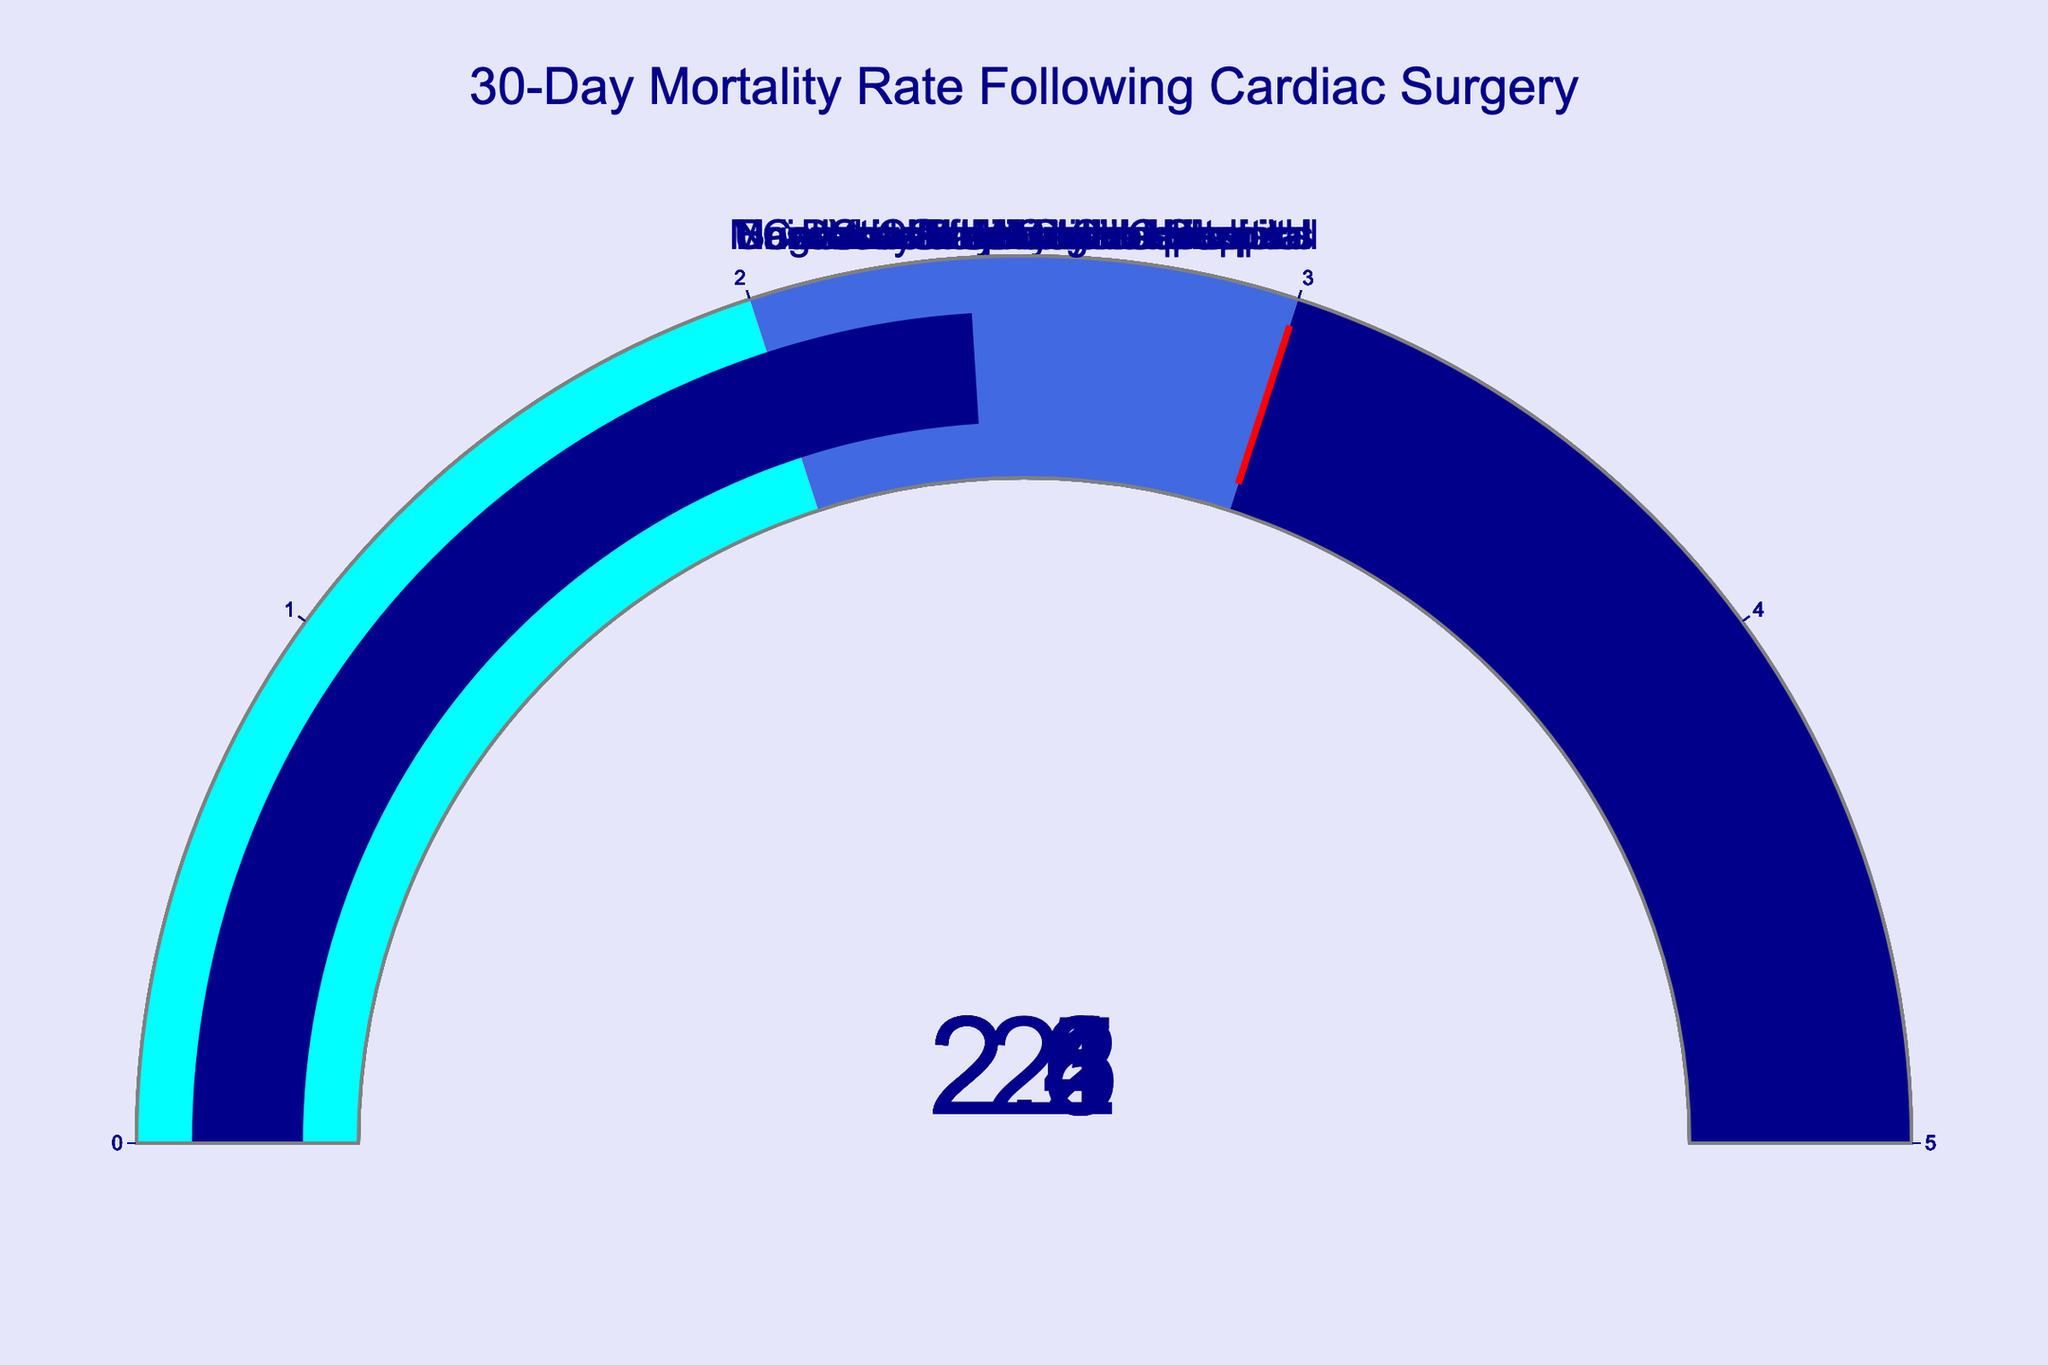What's the highest 30-day mortality rate displayed? The highest mortality rate is found by looking at each gauge and identifying the largest value shown among them. Cedars-Sinai Medical Center has the rate of 2.6.
Answer: 2.6 How many hospitals have a 30-day mortality rate above 2.2? Count the number of gauges where the value exceeds 2.2. These hospitals are Cleveland Clinic, Johns Hopkins Hospital, New York-Presbyterian Hospital, Cedars-Sinai Medical Center, and University of Michigan Hospitals, making a total of 5 hospitals.
Answer: 5 Which hospital has the lowest 30-day mortality rate? By scanning the gauges for the minimum value, Stanford Health Care shows the lowest rate of 2.0.
Answer: Stanford Health Care What is the range (difference between highest and lowest) of the 30-day mortality rates shown? Identify the highest rate (2.6) and the lowest rate (2.0) and calculate the difference, which is 2.6 - 2.0 = 0.6.
Answer: 0.6 How many hospitals have a 30-day mortality rate between 2.0 and 2.3 inclusive? Count the number of gauges with values within this range. These hospitals are Mayo Clinic, Cleveland Clinic, Massachusetts General Hospital, Stanford Health Care, Duke University Hospital, and Brigham and Women's Hospital, making a total of 6 hospitals.
Answer: 6 What is the average 30-day mortality rate of all the hospitals shown? Sum all the rates: 2.1 + 2.3 + 2.5 + 2.2 + 2.4 + 2.0 + 2.3 + 2.2 + 2.6 + 2.4 = 23.0. Divide by the number of hospitals (10), yielding an average of 2.3.
Answer: 2.3 If a new hospital has a 30-day mortality rate of 2.5, how many hospitals will have a lower rate than this new hospital? Count the gauges with values below 2.5. These hospitals are Mayo Clinic, Cleveland Clinic, Massachusetts General Hospital, New York-Presbyterian Hospital, Stanford Health Care, Duke University Hospital, Brigham and Women's Hospital, and University of Michigan Hospitals, making a total of 8 hospitals.
Answer: 8 Which hospitals have a 30-day mortality rate exactly equal to 2.3? Identify the hospitals with gauges displaying a value of 2.3. These hospitals are Cleveland Clinic and Duke University Hospital.
Answer: Cleveland Clinic and Duke University Hospital 